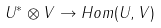<formula> <loc_0><loc_0><loc_500><loc_500>U ^ { * } \otimes V \to H o m ( U , V )</formula> 